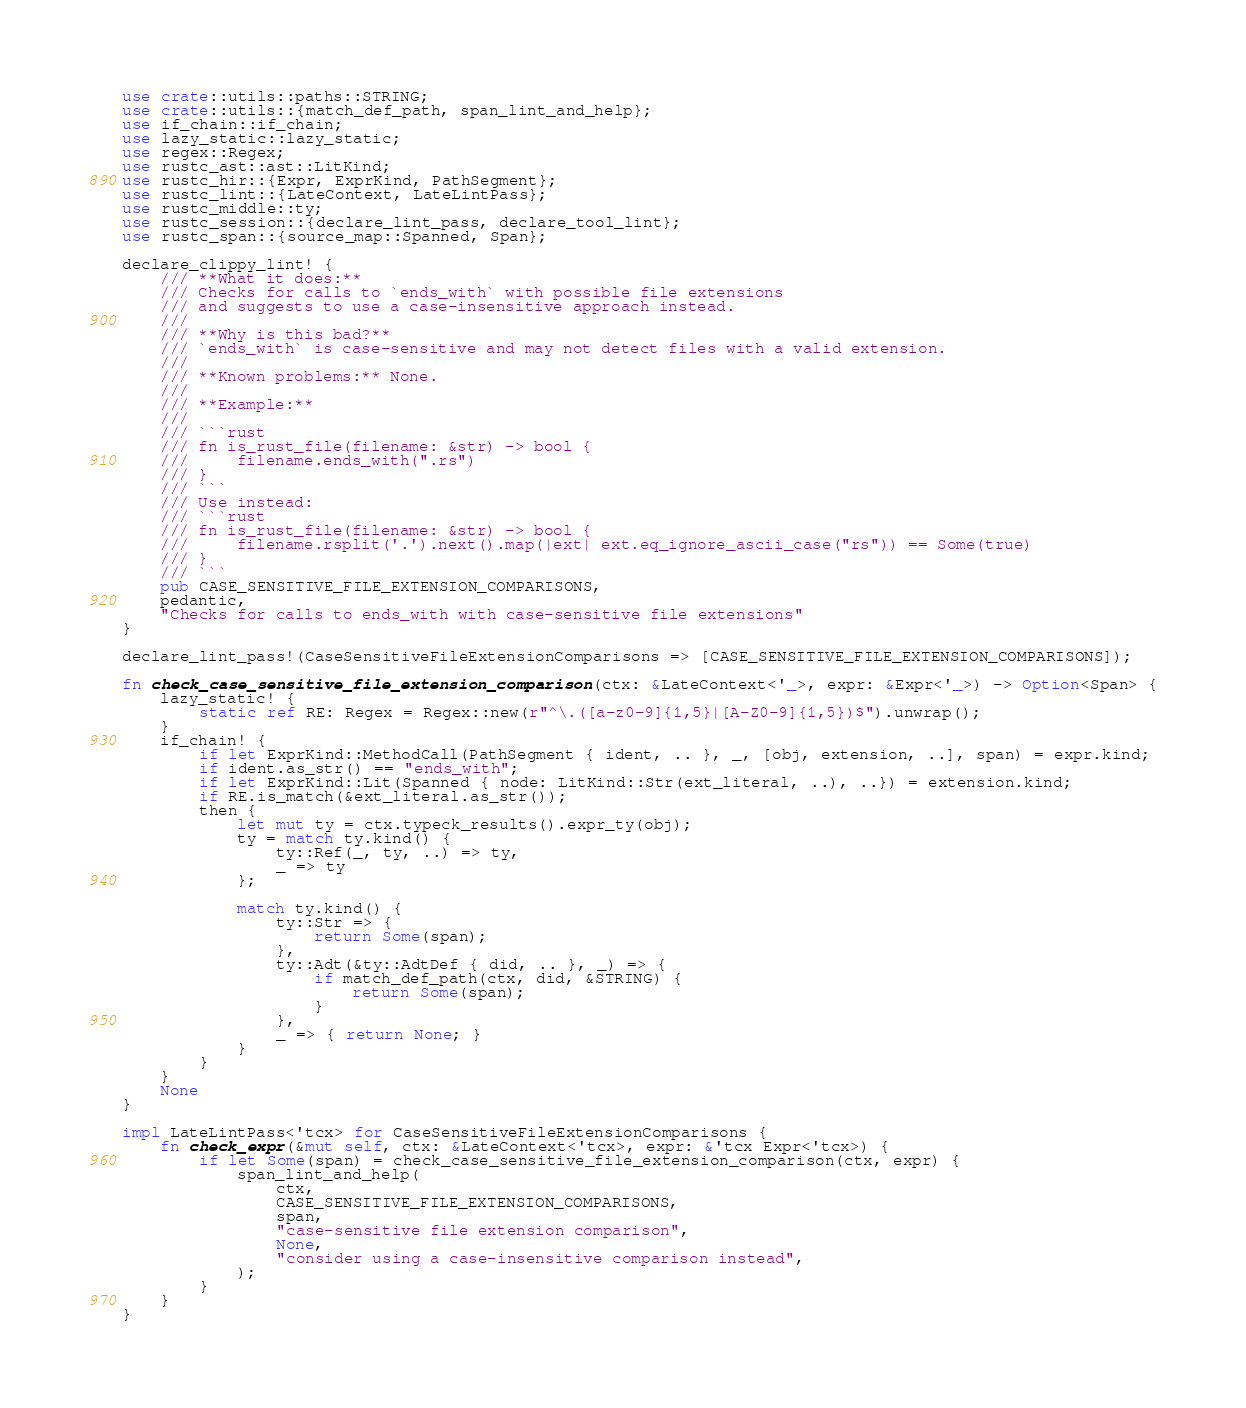Convert code to text. <code><loc_0><loc_0><loc_500><loc_500><_Rust_>use crate::utils::paths::STRING;
use crate::utils::{match_def_path, span_lint_and_help};
use if_chain::if_chain;
use lazy_static::lazy_static;
use regex::Regex;
use rustc_ast::ast::LitKind;
use rustc_hir::{Expr, ExprKind, PathSegment};
use rustc_lint::{LateContext, LateLintPass};
use rustc_middle::ty;
use rustc_session::{declare_lint_pass, declare_tool_lint};
use rustc_span::{source_map::Spanned, Span};

declare_clippy_lint! {
    /// **What it does:**
    /// Checks for calls to `ends_with` with possible file extensions
    /// and suggests to use a case-insensitive approach instead.
    ///
    /// **Why is this bad?**
    /// `ends_with` is case-sensitive and may not detect files with a valid extension.
    ///
    /// **Known problems:** None.
    ///
    /// **Example:**
    ///
    /// ```rust
    /// fn is_rust_file(filename: &str) -> bool {
    ///     filename.ends_with(".rs")
    /// }
    /// ```
    /// Use instead:
    /// ```rust
    /// fn is_rust_file(filename: &str) -> bool {
    ///     filename.rsplit('.').next().map(|ext| ext.eq_ignore_ascii_case("rs")) == Some(true)
    /// }
    /// ```
    pub CASE_SENSITIVE_FILE_EXTENSION_COMPARISONS,
    pedantic,
    "Checks for calls to ends_with with case-sensitive file extensions"
}

declare_lint_pass!(CaseSensitiveFileExtensionComparisons => [CASE_SENSITIVE_FILE_EXTENSION_COMPARISONS]);

fn check_case_sensitive_file_extension_comparison(ctx: &LateContext<'_>, expr: &Expr<'_>) -> Option<Span> {
    lazy_static! {
        static ref RE: Regex = Regex::new(r"^\.([a-z0-9]{1,5}|[A-Z0-9]{1,5})$").unwrap();
    }
    if_chain! {
        if let ExprKind::MethodCall(PathSegment { ident, .. }, _, [obj, extension, ..], span) = expr.kind;
        if ident.as_str() == "ends_with";
        if let ExprKind::Lit(Spanned { node: LitKind::Str(ext_literal, ..), ..}) = extension.kind;
        if RE.is_match(&ext_literal.as_str());
        then {
            let mut ty = ctx.typeck_results().expr_ty(obj);
            ty = match ty.kind() {
                ty::Ref(_, ty, ..) => ty,
                _ => ty
            };

            match ty.kind() {
                ty::Str => {
                    return Some(span);
                },
                ty::Adt(&ty::AdtDef { did, .. }, _) => {
                    if match_def_path(ctx, did, &STRING) {
                        return Some(span);
                    }
                },
                _ => { return None; }
            }
        }
    }
    None
}

impl LateLintPass<'tcx> for CaseSensitiveFileExtensionComparisons {
    fn check_expr(&mut self, ctx: &LateContext<'tcx>, expr: &'tcx Expr<'tcx>) {
        if let Some(span) = check_case_sensitive_file_extension_comparison(ctx, expr) {
            span_lint_and_help(
                ctx,
                CASE_SENSITIVE_FILE_EXTENSION_COMPARISONS,
                span,
                "case-sensitive file extension comparison",
                None,
                "consider using a case-insensitive comparison instead",
            );
        }
    }
}
</code> 